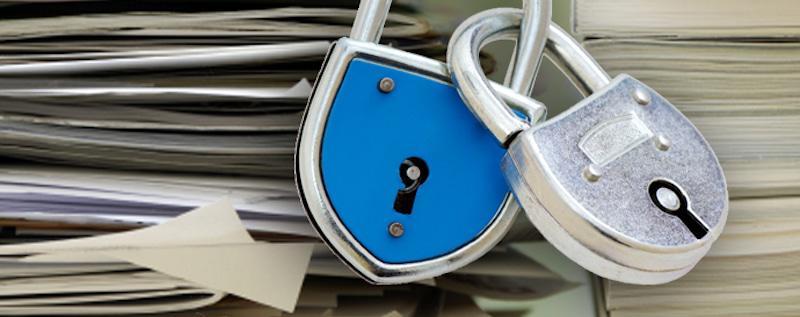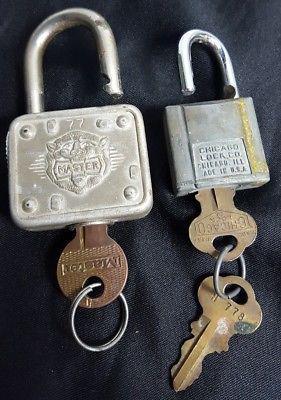The first image is the image on the left, the second image is the image on the right. Assess this claim about the two images: "The right image has at least two keys.". Correct or not? Answer yes or no. Yes. The first image is the image on the left, the second image is the image on the right. Given the left and right images, does the statement "There are two separate keys inserted into the locks." hold true? Answer yes or no. Yes. 